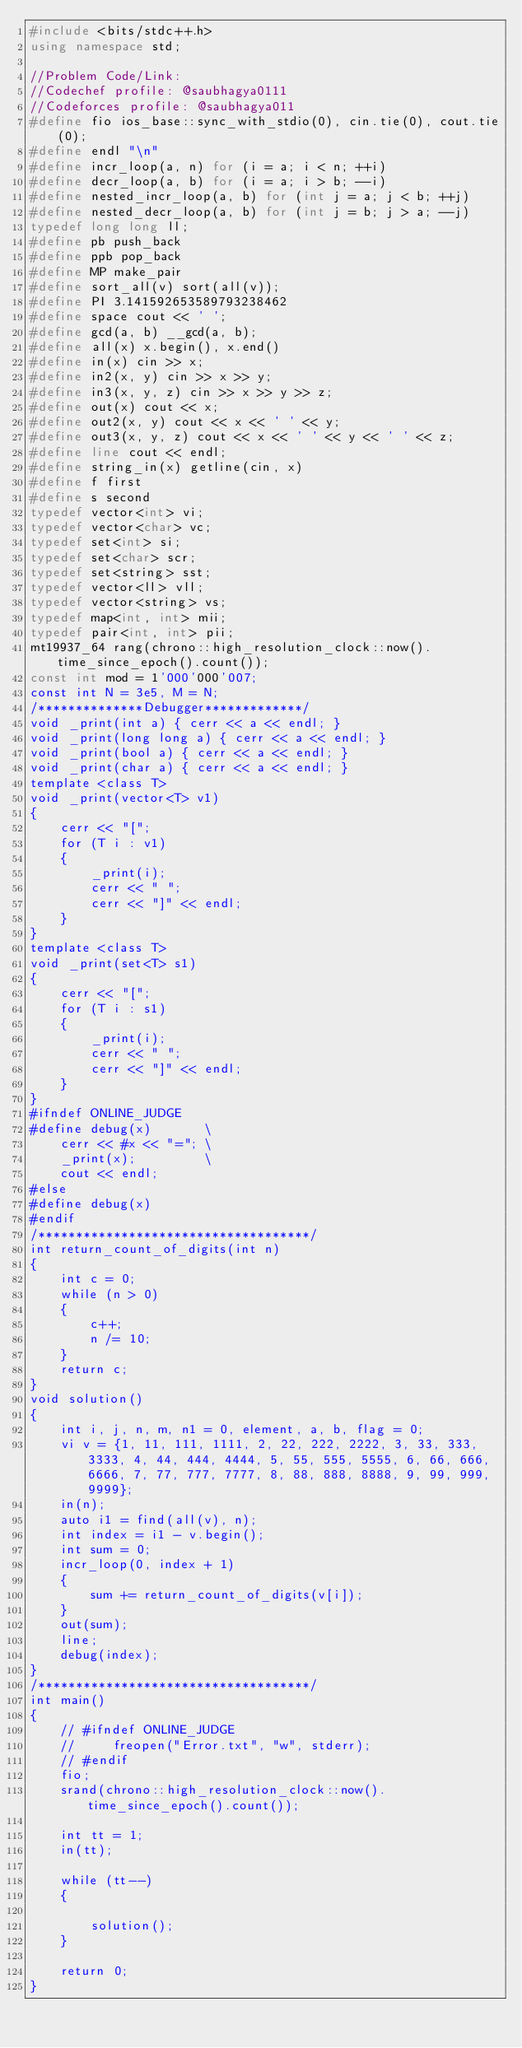<code> <loc_0><loc_0><loc_500><loc_500><_C++_>#include <bits/stdc++.h>
using namespace std;

//Problem Code/Link:
//Codechef profile: @saubhagya0111
//Codeforces profile: @saubhagya011
#define fio ios_base::sync_with_stdio(0), cin.tie(0), cout.tie(0);
#define endl "\n"
#define incr_loop(a, n) for (i = a; i < n; ++i)
#define decr_loop(a, b) for (i = a; i > b; --i)
#define nested_incr_loop(a, b) for (int j = a; j < b; ++j)
#define nested_decr_loop(a, b) for (int j = b; j > a; --j)
typedef long long ll;
#define pb push_back
#define ppb pop_back
#define MP make_pair
#define sort_all(v) sort(all(v));
#define PI 3.141592653589793238462
#define space cout << ' ';
#define gcd(a, b) __gcd(a, b);
#define all(x) x.begin(), x.end()
#define in(x) cin >> x;
#define in2(x, y) cin >> x >> y;
#define in3(x, y, z) cin >> x >> y >> z;
#define out(x) cout << x;
#define out2(x, y) cout << x << ' ' << y;
#define out3(x, y, z) cout << x << ' ' << y << ' ' << z;
#define line cout << endl;
#define string_in(x) getline(cin, x)
#define f first
#define s second
typedef vector<int> vi;
typedef vector<char> vc;
typedef set<int> si;
typedef set<char> scr;
typedef set<string> sst;
typedef vector<ll> vll;
typedef vector<string> vs;
typedef map<int, int> mii;
typedef pair<int, int> pii;
mt19937_64 rang(chrono::high_resolution_clock::now().time_since_epoch().count());
const int mod = 1'000'000'007;
const int N = 3e5, M = N;
/**************Debugger*************/
void _print(int a) { cerr << a << endl; }
void _print(long long a) { cerr << a << endl; }
void _print(bool a) { cerr << a << endl; }
void _print(char a) { cerr << a << endl; }
template <class T>
void _print(vector<T> v1)
{
    cerr << "[";
    for (T i : v1)
    {
        _print(i);
        cerr << " ";
        cerr << "]" << endl;
    }
}
template <class T>
void _print(set<T> s1)
{
    cerr << "[";
    for (T i : s1)
    {
        _print(i);
        cerr << " ";
        cerr << "]" << endl;
    }
}
#ifndef ONLINE_JUDGE
#define debug(x)       \
    cerr << #x << "="; \
    _print(x);         \
    cout << endl;
#else
#define debug(x)
#endif
/************************************/
int return_count_of_digits(int n)
{
    int c = 0;
    while (n > 0)
    {
        c++;
        n /= 10;
    }
    return c;
}
void solution()
{
    int i, j, n, m, n1 = 0, element, a, b, flag = 0;
    vi v = {1, 11, 111, 1111, 2, 22, 222, 2222, 3, 33, 333, 3333, 4, 44, 444, 4444, 5, 55, 555, 5555, 6, 66, 666, 6666, 7, 77, 777, 7777, 8, 88, 888, 8888, 9, 99, 999, 9999};
    in(n);
    auto i1 = find(all(v), n);
    int index = i1 - v.begin();
    int sum = 0;
    incr_loop(0, index + 1)
    {
        sum += return_count_of_digits(v[i]);
    }
    out(sum);
    line;
    debug(index);
}
/************************************/
int main()
{
    // #ifndef ONLINE_JUDGE
    //     freopen("Error.txt", "w", stderr);
    // #endif
    fio;
    srand(chrono::high_resolution_clock::now().time_since_epoch().count());

    int tt = 1;
    in(tt);

    while (tt--)
    {

        solution();
    }

    return 0;
}
</code> 